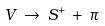<formula> <loc_0><loc_0><loc_500><loc_500>V \, \rightarrow \, S ^ { + } \, + \, \pi</formula> 